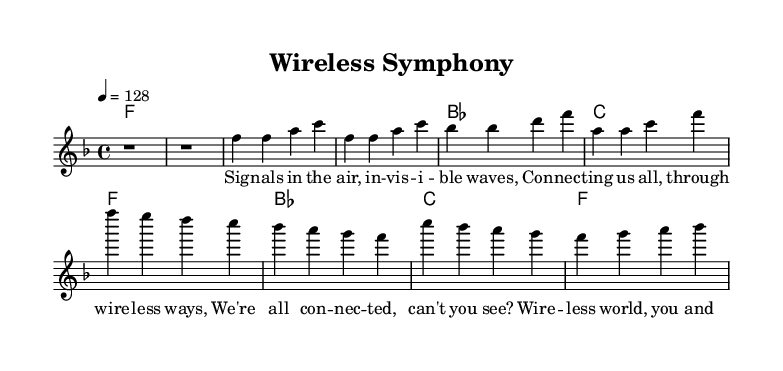What is the key signature of this music? The key signature is F major, which has one flat (B flat).
Answer: F major What is the time signature of the piece? The time signature is 4/4, indicating four beats per measure.
Answer: 4/4 What is the tempo marking for this piece? The tempo marking is indicated as "4 = 128," meaning there are 128 beats per minute.
Answer: 128 How many measures are in the chorus section? The chorus consists of four measures based on the notation.
Answer: 4 What is the first lyric phrase of the verse? The first lyric phrase is "Signals in the air, invisible waves," indicating the start of the verse section.
Answer: Signals in the air, invisible waves How does the harmony relate to the melody in the chorus? The harmony progresses through F to B flat to C, supporting the melody that emphasizes connecting themes, creating a cohesive sound. This progression offers a strong foundation for the upbeat feel typical of house music.
Answer: F, B flat, C 